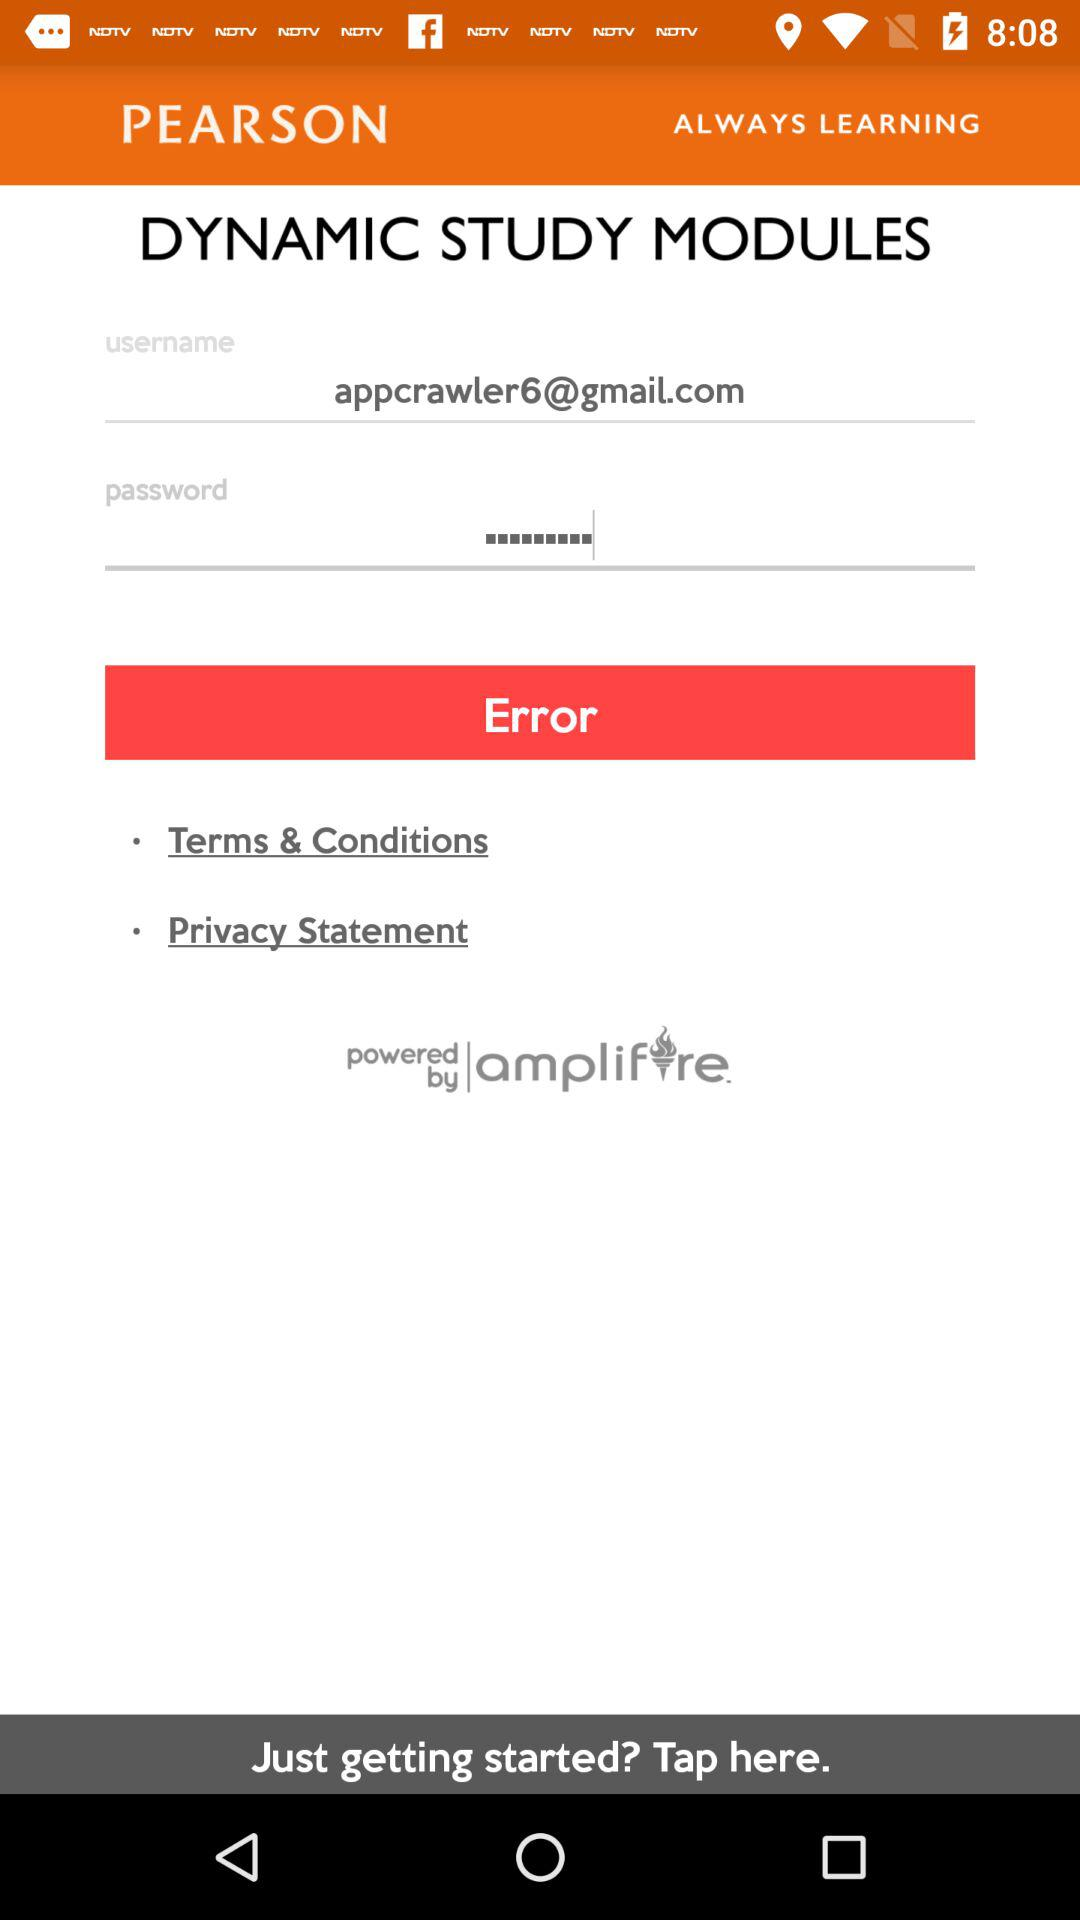What is the name of the application? The name of the application is "DYNAMIC STUDY MODULES". 